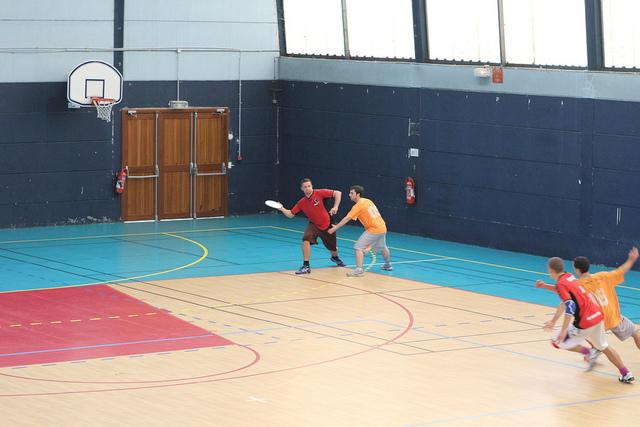What game is usually played on this court? Please explain your reasoning. basketball. A group of boys are playing frisbee in an indoor court. there is a hoop in the background. 